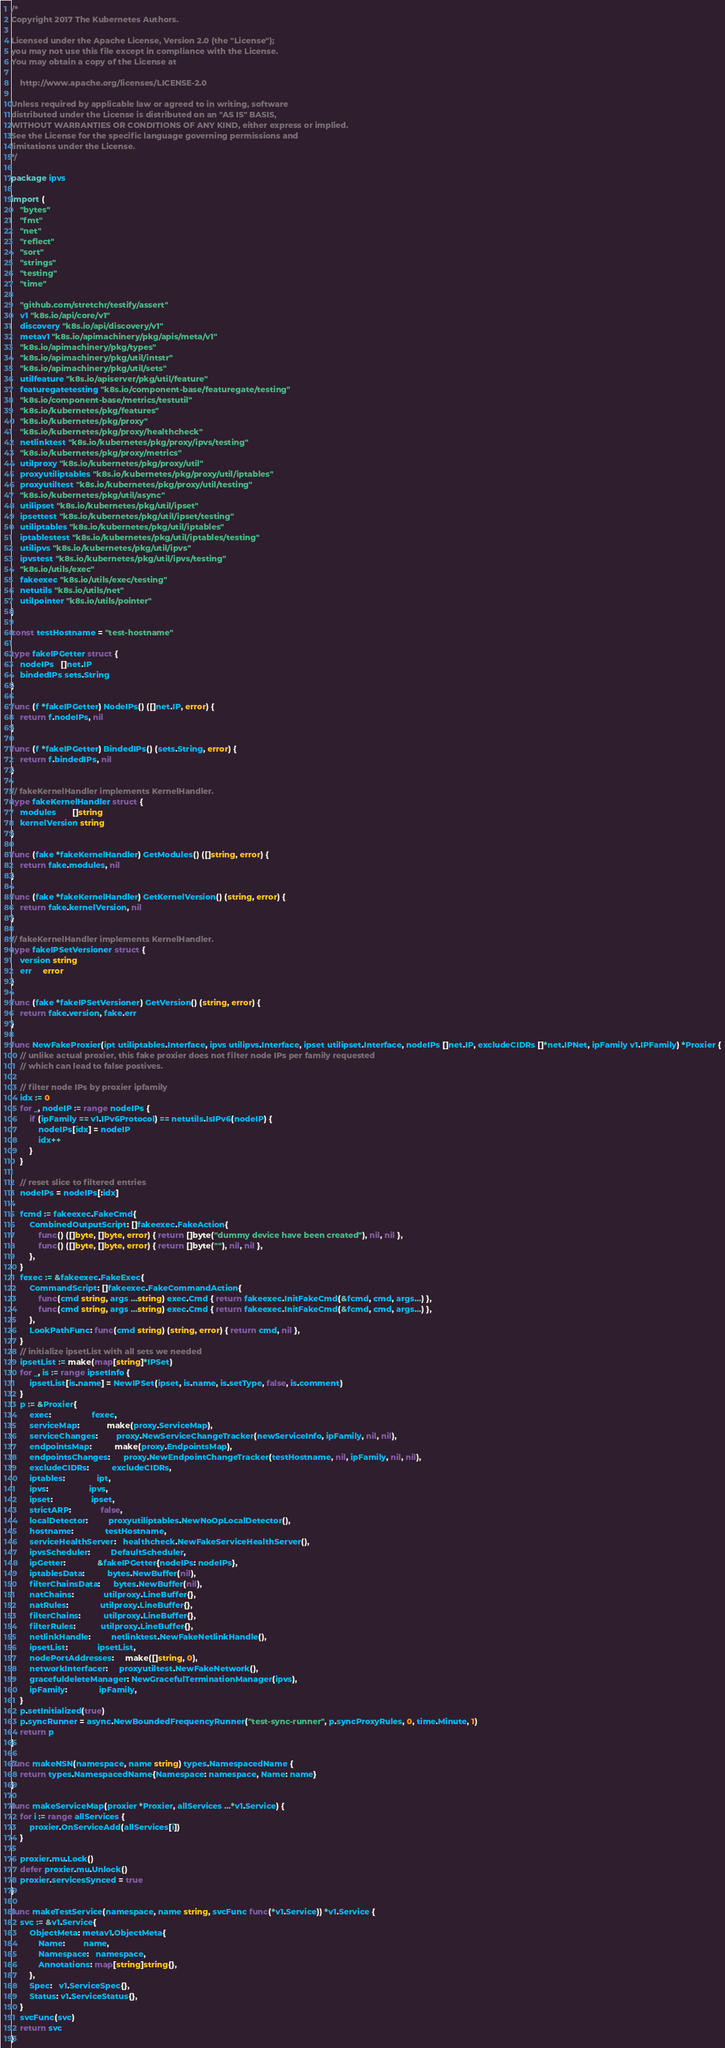<code> <loc_0><loc_0><loc_500><loc_500><_Go_>/*
Copyright 2017 The Kubernetes Authors.

Licensed under the Apache License, Version 2.0 (the "License");
you may not use this file except in compliance with the License.
You may obtain a copy of the License at

    http://www.apache.org/licenses/LICENSE-2.0

Unless required by applicable law or agreed to in writing, software
distributed under the License is distributed on an "AS IS" BASIS,
WITHOUT WARRANTIES OR CONDITIONS OF ANY KIND, either express or implied.
See the License for the specific language governing permissions and
limitations under the License.
*/

package ipvs

import (
	"bytes"
	"fmt"
	"net"
	"reflect"
	"sort"
	"strings"
	"testing"
	"time"

	"github.com/stretchr/testify/assert"
	v1 "k8s.io/api/core/v1"
	discovery "k8s.io/api/discovery/v1"
	metav1 "k8s.io/apimachinery/pkg/apis/meta/v1"
	"k8s.io/apimachinery/pkg/types"
	"k8s.io/apimachinery/pkg/util/intstr"
	"k8s.io/apimachinery/pkg/util/sets"
	utilfeature "k8s.io/apiserver/pkg/util/feature"
	featuregatetesting "k8s.io/component-base/featuregate/testing"
	"k8s.io/component-base/metrics/testutil"
	"k8s.io/kubernetes/pkg/features"
	"k8s.io/kubernetes/pkg/proxy"
	"k8s.io/kubernetes/pkg/proxy/healthcheck"
	netlinktest "k8s.io/kubernetes/pkg/proxy/ipvs/testing"
	"k8s.io/kubernetes/pkg/proxy/metrics"
	utilproxy "k8s.io/kubernetes/pkg/proxy/util"
	proxyutiliptables "k8s.io/kubernetes/pkg/proxy/util/iptables"
	proxyutiltest "k8s.io/kubernetes/pkg/proxy/util/testing"
	"k8s.io/kubernetes/pkg/util/async"
	utilipset "k8s.io/kubernetes/pkg/util/ipset"
	ipsettest "k8s.io/kubernetes/pkg/util/ipset/testing"
	utiliptables "k8s.io/kubernetes/pkg/util/iptables"
	iptablestest "k8s.io/kubernetes/pkg/util/iptables/testing"
	utilipvs "k8s.io/kubernetes/pkg/util/ipvs"
	ipvstest "k8s.io/kubernetes/pkg/util/ipvs/testing"
	"k8s.io/utils/exec"
	fakeexec "k8s.io/utils/exec/testing"
	netutils "k8s.io/utils/net"
	utilpointer "k8s.io/utils/pointer"
)

const testHostname = "test-hostname"

type fakeIPGetter struct {
	nodeIPs   []net.IP
	bindedIPs sets.String
}

func (f *fakeIPGetter) NodeIPs() ([]net.IP, error) {
	return f.nodeIPs, nil
}

func (f *fakeIPGetter) BindedIPs() (sets.String, error) {
	return f.bindedIPs, nil
}

// fakeKernelHandler implements KernelHandler.
type fakeKernelHandler struct {
	modules       []string
	kernelVersion string
}

func (fake *fakeKernelHandler) GetModules() ([]string, error) {
	return fake.modules, nil
}

func (fake *fakeKernelHandler) GetKernelVersion() (string, error) {
	return fake.kernelVersion, nil
}

// fakeKernelHandler implements KernelHandler.
type fakeIPSetVersioner struct {
	version string
	err     error
}

func (fake *fakeIPSetVersioner) GetVersion() (string, error) {
	return fake.version, fake.err
}

func NewFakeProxier(ipt utiliptables.Interface, ipvs utilipvs.Interface, ipset utilipset.Interface, nodeIPs []net.IP, excludeCIDRs []*net.IPNet, ipFamily v1.IPFamily) *Proxier {
	// unlike actual proxier, this fake proxier does not filter node IPs per family requested
	// which can lead to false postives.

	// filter node IPs by proxier ipfamily
	idx := 0
	for _, nodeIP := range nodeIPs {
		if (ipFamily == v1.IPv6Protocol) == netutils.IsIPv6(nodeIP) {
			nodeIPs[idx] = nodeIP
			idx++
		}
	}

	// reset slice to filtered entries
	nodeIPs = nodeIPs[:idx]

	fcmd := fakeexec.FakeCmd{
		CombinedOutputScript: []fakeexec.FakeAction{
			func() ([]byte, []byte, error) { return []byte("dummy device have been created"), nil, nil },
			func() ([]byte, []byte, error) { return []byte(""), nil, nil },
		},
	}
	fexec := &fakeexec.FakeExec{
		CommandScript: []fakeexec.FakeCommandAction{
			func(cmd string, args ...string) exec.Cmd { return fakeexec.InitFakeCmd(&fcmd, cmd, args...) },
			func(cmd string, args ...string) exec.Cmd { return fakeexec.InitFakeCmd(&fcmd, cmd, args...) },
		},
		LookPathFunc: func(cmd string) (string, error) { return cmd, nil },
	}
	// initialize ipsetList with all sets we needed
	ipsetList := make(map[string]*IPSet)
	for _, is := range ipsetInfo {
		ipsetList[is.name] = NewIPSet(ipset, is.name, is.setType, false, is.comment)
	}
	p := &Proxier{
		exec:                  fexec,
		serviceMap:            make(proxy.ServiceMap),
		serviceChanges:        proxy.NewServiceChangeTracker(newServiceInfo, ipFamily, nil, nil),
		endpointsMap:          make(proxy.EndpointsMap),
		endpointsChanges:      proxy.NewEndpointChangeTracker(testHostname, nil, ipFamily, nil, nil),
		excludeCIDRs:          excludeCIDRs,
		iptables:              ipt,
		ipvs:                  ipvs,
		ipset:                 ipset,
		strictARP:             false,
		localDetector:         proxyutiliptables.NewNoOpLocalDetector(),
		hostname:              testHostname,
		serviceHealthServer:   healthcheck.NewFakeServiceHealthServer(),
		ipvsScheduler:         DefaultScheduler,
		ipGetter:              &fakeIPGetter{nodeIPs: nodeIPs},
		iptablesData:          bytes.NewBuffer(nil),
		filterChainsData:      bytes.NewBuffer(nil),
		natChains:             utilproxy.LineBuffer{},
		natRules:              utilproxy.LineBuffer{},
		filterChains:          utilproxy.LineBuffer{},
		filterRules:           utilproxy.LineBuffer{},
		netlinkHandle:         netlinktest.NewFakeNetlinkHandle(),
		ipsetList:             ipsetList,
		nodePortAddresses:     make([]string, 0),
		networkInterfacer:     proxyutiltest.NewFakeNetwork(),
		gracefuldeleteManager: NewGracefulTerminationManager(ipvs),
		ipFamily:              ipFamily,
	}
	p.setInitialized(true)
	p.syncRunner = async.NewBoundedFrequencyRunner("test-sync-runner", p.syncProxyRules, 0, time.Minute, 1)
	return p
}

func makeNSN(namespace, name string) types.NamespacedName {
	return types.NamespacedName{Namespace: namespace, Name: name}
}

func makeServiceMap(proxier *Proxier, allServices ...*v1.Service) {
	for i := range allServices {
		proxier.OnServiceAdd(allServices[i])
	}

	proxier.mu.Lock()
	defer proxier.mu.Unlock()
	proxier.servicesSynced = true
}

func makeTestService(namespace, name string, svcFunc func(*v1.Service)) *v1.Service {
	svc := &v1.Service{
		ObjectMeta: metav1.ObjectMeta{
			Name:        name,
			Namespace:   namespace,
			Annotations: map[string]string{},
		},
		Spec:   v1.ServiceSpec{},
		Status: v1.ServiceStatus{},
	}
	svcFunc(svc)
	return svc
}
</code> 